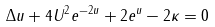<formula> <loc_0><loc_0><loc_500><loc_500>\Delta u + 4 \| U \| ^ { 2 } e ^ { - 2 u } + 2 e ^ { u } - 2 \kappa = 0</formula> 